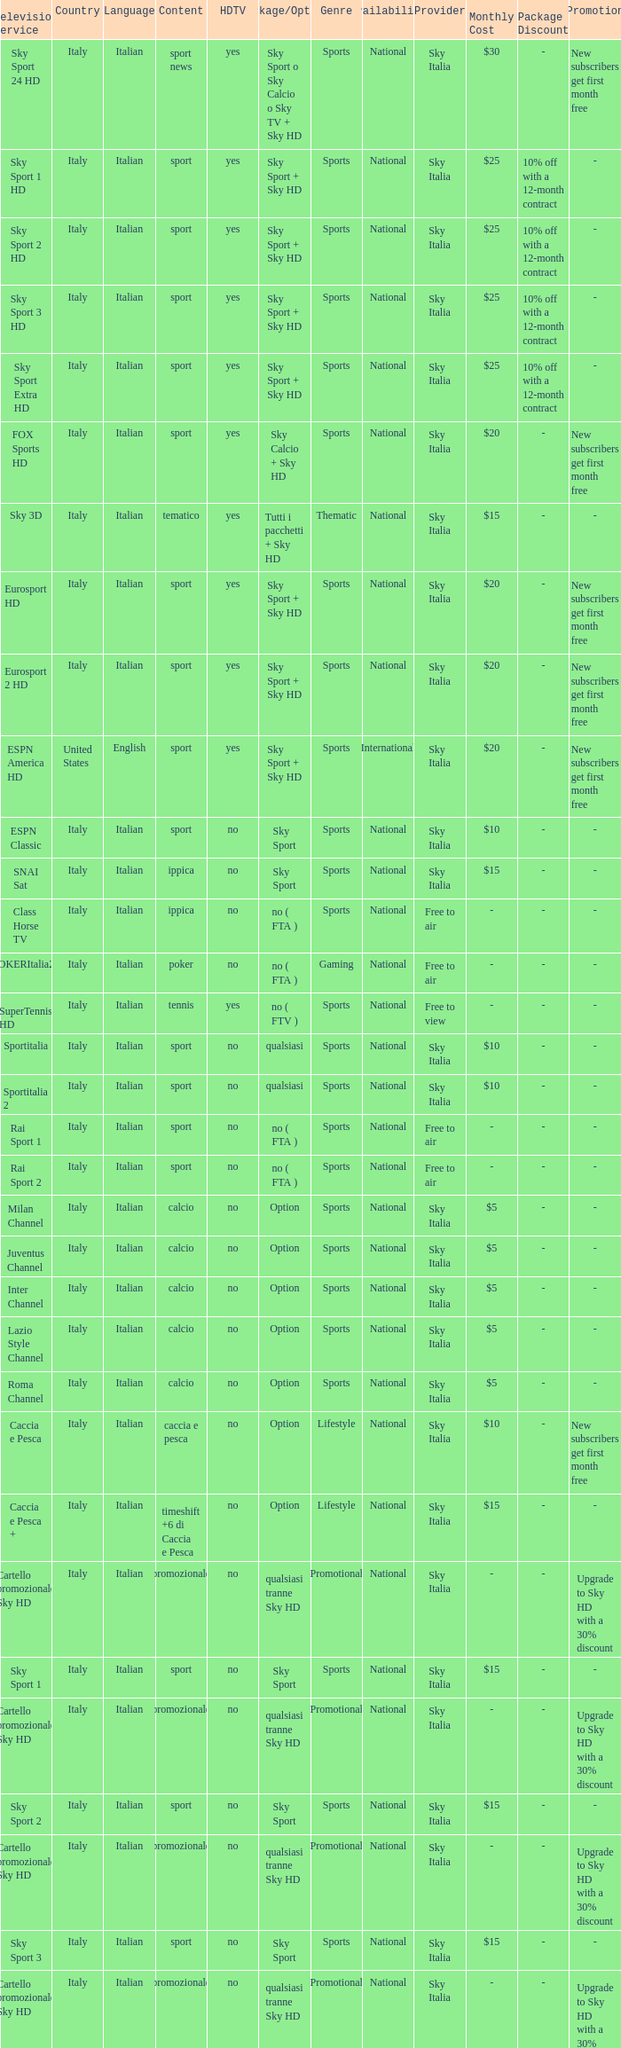What is Language, when Content is Sport, when HDTV is No, and when Television Service is ESPN America? Italian. 